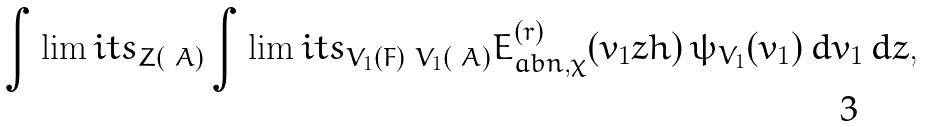<formula> <loc_0><loc_0><loc_500><loc_500>\int \lim i t s _ { Z ( { \ A } ) } \int \lim i t s _ { V _ { 1 } ( F ) \ V _ { 1 } ( { \ A } ) } E _ { a b n , \chi } ^ { ( r ) } ( v _ { 1 } z h ) \, \psi _ { V _ { 1 } } ( v _ { 1 } ) \, d v _ { 1 } \, d z ,</formula> 